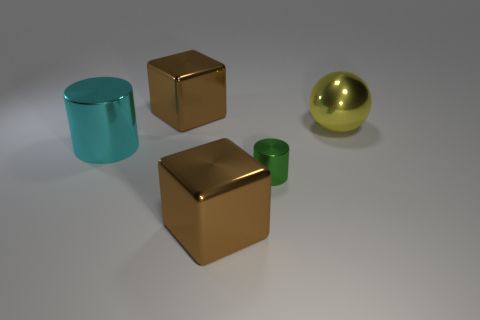Are there any other things that are the same size as the green object?
Your response must be concise. No. There is a brown shiny object that is in front of the big metallic ball; what shape is it?
Keep it short and to the point. Cube. The small thing is what color?
Offer a terse response. Green. What number of other objects are there of the same size as the cyan object?
Your answer should be very brief. 3. There is a metal ball; does it have the same size as the brown object that is in front of the green metallic object?
Ensure brevity in your answer.  Yes. What number of tiny objects are yellow spheres or yellow matte cubes?
Your answer should be compact. 0. What number of big brown metal objects are there?
Ensure brevity in your answer.  2. What is the brown thing that is in front of the green cylinder made of?
Make the answer very short. Metal. Are there any large brown metallic things behind the green metal thing?
Offer a very short reply. Yes. Do the yellow sphere and the cyan shiny thing have the same size?
Offer a terse response. Yes. 